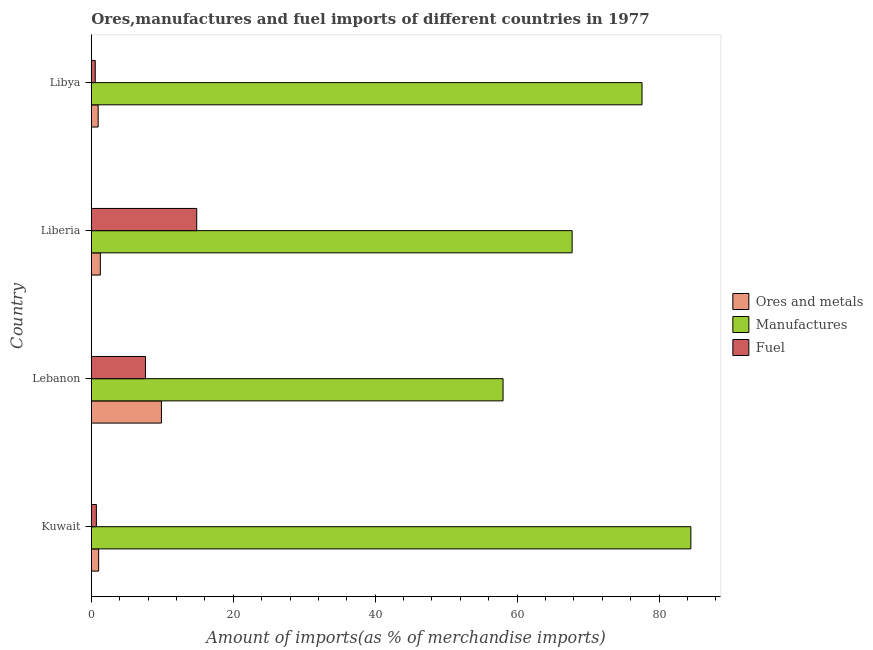How many different coloured bars are there?
Make the answer very short. 3. Are the number of bars per tick equal to the number of legend labels?
Offer a terse response. Yes. How many bars are there on the 3rd tick from the top?
Provide a short and direct response. 3. What is the label of the 3rd group of bars from the top?
Provide a succinct answer. Lebanon. In how many cases, is the number of bars for a given country not equal to the number of legend labels?
Offer a very short reply. 0. What is the percentage of manufactures imports in Libya?
Provide a succinct answer. 77.6. Across all countries, what is the maximum percentage of manufactures imports?
Keep it short and to the point. 84.49. Across all countries, what is the minimum percentage of fuel imports?
Give a very brief answer. 0.56. In which country was the percentage of fuel imports maximum?
Offer a very short reply. Liberia. In which country was the percentage of ores and metals imports minimum?
Offer a very short reply. Libya. What is the total percentage of fuel imports in the graph?
Make the answer very short. 23.76. What is the difference between the percentage of fuel imports in Kuwait and that in Lebanon?
Give a very brief answer. -6.92. What is the difference between the percentage of manufactures imports in Kuwait and the percentage of fuel imports in Libya?
Give a very brief answer. 83.93. What is the average percentage of fuel imports per country?
Provide a short and direct response. 5.94. What is the difference between the percentage of manufactures imports and percentage of ores and metals imports in Libya?
Give a very brief answer. 76.64. In how many countries, is the percentage of ores and metals imports greater than 72 %?
Offer a terse response. 0. What is the ratio of the percentage of manufactures imports in Kuwait to that in Libya?
Make the answer very short. 1.09. Is the difference between the percentage of manufactures imports in Kuwait and Lebanon greater than the difference between the percentage of fuel imports in Kuwait and Lebanon?
Your answer should be very brief. Yes. What is the difference between the highest and the second highest percentage of ores and metals imports?
Your answer should be very brief. 8.61. What is the difference between the highest and the lowest percentage of ores and metals imports?
Ensure brevity in your answer.  8.92. What does the 3rd bar from the top in Liberia represents?
Your answer should be compact. Ores and metals. What does the 3rd bar from the bottom in Libya represents?
Ensure brevity in your answer.  Fuel. Is it the case that in every country, the sum of the percentage of ores and metals imports and percentage of manufactures imports is greater than the percentage of fuel imports?
Give a very brief answer. Yes. How many bars are there?
Your answer should be very brief. 12. How many countries are there in the graph?
Provide a short and direct response. 4. Are the values on the major ticks of X-axis written in scientific E-notation?
Make the answer very short. No. Does the graph contain any zero values?
Your answer should be very brief. No. Where does the legend appear in the graph?
Make the answer very short. Center right. What is the title of the graph?
Provide a succinct answer. Ores,manufactures and fuel imports of different countries in 1977. Does "Unemployment benefits" appear as one of the legend labels in the graph?
Give a very brief answer. No. What is the label or title of the X-axis?
Keep it short and to the point. Amount of imports(as % of merchandise imports). What is the Amount of imports(as % of merchandise imports) in Ores and metals in Kuwait?
Provide a succinct answer. 1.04. What is the Amount of imports(as % of merchandise imports) in Manufactures in Kuwait?
Keep it short and to the point. 84.49. What is the Amount of imports(as % of merchandise imports) in Fuel in Kuwait?
Give a very brief answer. 0.71. What is the Amount of imports(as % of merchandise imports) of Ores and metals in Lebanon?
Make the answer very short. 9.88. What is the Amount of imports(as % of merchandise imports) of Manufactures in Lebanon?
Make the answer very short. 58.02. What is the Amount of imports(as % of merchandise imports) in Fuel in Lebanon?
Offer a very short reply. 7.63. What is the Amount of imports(as % of merchandise imports) in Ores and metals in Liberia?
Your answer should be compact. 1.27. What is the Amount of imports(as % of merchandise imports) in Manufactures in Liberia?
Your answer should be compact. 67.76. What is the Amount of imports(as % of merchandise imports) of Fuel in Liberia?
Provide a succinct answer. 14.86. What is the Amount of imports(as % of merchandise imports) of Ores and metals in Libya?
Your response must be concise. 0.97. What is the Amount of imports(as % of merchandise imports) of Manufactures in Libya?
Give a very brief answer. 77.6. What is the Amount of imports(as % of merchandise imports) in Fuel in Libya?
Make the answer very short. 0.56. Across all countries, what is the maximum Amount of imports(as % of merchandise imports) of Ores and metals?
Offer a very short reply. 9.88. Across all countries, what is the maximum Amount of imports(as % of merchandise imports) of Manufactures?
Offer a very short reply. 84.49. Across all countries, what is the maximum Amount of imports(as % of merchandise imports) in Fuel?
Make the answer very short. 14.86. Across all countries, what is the minimum Amount of imports(as % of merchandise imports) in Ores and metals?
Provide a succinct answer. 0.97. Across all countries, what is the minimum Amount of imports(as % of merchandise imports) of Manufactures?
Ensure brevity in your answer.  58.02. Across all countries, what is the minimum Amount of imports(as % of merchandise imports) of Fuel?
Make the answer very short. 0.56. What is the total Amount of imports(as % of merchandise imports) in Ores and metals in the graph?
Your answer should be very brief. 13.16. What is the total Amount of imports(as % of merchandise imports) of Manufactures in the graph?
Offer a very short reply. 287.87. What is the total Amount of imports(as % of merchandise imports) in Fuel in the graph?
Give a very brief answer. 23.76. What is the difference between the Amount of imports(as % of merchandise imports) of Ores and metals in Kuwait and that in Lebanon?
Your answer should be compact. -8.85. What is the difference between the Amount of imports(as % of merchandise imports) of Manufactures in Kuwait and that in Lebanon?
Give a very brief answer. 26.46. What is the difference between the Amount of imports(as % of merchandise imports) in Fuel in Kuwait and that in Lebanon?
Offer a very short reply. -6.92. What is the difference between the Amount of imports(as % of merchandise imports) of Ores and metals in Kuwait and that in Liberia?
Give a very brief answer. -0.24. What is the difference between the Amount of imports(as % of merchandise imports) in Manufactures in Kuwait and that in Liberia?
Your answer should be compact. 16.73. What is the difference between the Amount of imports(as % of merchandise imports) of Fuel in Kuwait and that in Liberia?
Your answer should be very brief. -14.14. What is the difference between the Amount of imports(as % of merchandise imports) of Ores and metals in Kuwait and that in Libya?
Provide a succinct answer. 0.07. What is the difference between the Amount of imports(as % of merchandise imports) in Manufactures in Kuwait and that in Libya?
Your response must be concise. 6.88. What is the difference between the Amount of imports(as % of merchandise imports) in Fuel in Kuwait and that in Libya?
Your response must be concise. 0.16. What is the difference between the Amount of imports(as % of merchandise imports) of Ores and metals in Lebanon and that in Liberia?
Offer a terse response. 8.61. What is the difference between the Amount of imports(as % of merchandise imports) in Manufactures in Lebanon and that in Liberia?
Keep it short and to the point. -9.73. What is the difference between the Amount of imports(as % of merchandise imports) of Fuel in Lebanon and that in Liberia?
Your answer should be compact. -7.22. What is the difference between the Amount of imports(as % of merchandise imports) in Ores and metals in Lebanon and that in Libya?
Your answer should be compact. 8.92. What is the difference between the Amount of imports(as % of merchandise imports) of Manufactures in Lebanon and that in Libya?
Give a very brief answer. -19.58. What is the difference between the Amount of imports(as % of merchandise imports) of Fuel in Lebanon and that in Libya?
Make the answer very short. 7.08. What is the difference between the Amount of imports(as % of merchandise imports) in Ores and metals in Liberia and that in Libya?
Provide a short and direct response. 0.31. What is the difference between the Amount of imports(as % of merchandise imports) in Manufactures in Liberia and that in Libya?
Your response must be concise. -9.85. What is the difference between the Amount of imports(as % of merchandise imports) of Fuel in Liberia and that in Libya?
Your answer should be very brief. 14.3. What is the difference between the Amount of imports(as % of merchandise imports) of Ores and metals in Kuwait and the Amount of imports(as % of merchandise imports) of Manufactures in Lebanon?
Provide a succinct answer. -56.99. What is the difference between the Amount of imports(as % of merchandise imports) of Ores and metals in Kuwait and the Amount of imports(as % of merchandise imports) of Fuel in Lebanon?
Make the answer very short. -6.6. What is the difference between the Amount of imports(as % of merchandise imports) in Manufactures in Kuwait and the Amount of imports(as % of merchandise imports) in Fuel in Lebanon?
Ensure brevity in your answer.  76.85. What is the difference between the Amount of imports(as % of merchandise imports) in Ores and metals in Kuwait and the Amount of imports(as % of merchandise imports) in Manufactures in Liberia?
Provide a succinct answer. -66.72. What is the difference between the Amount of imports(as % of merchandise imports) of Ores and metals in Kuwait and the Amount of imports(as % of merchandise imports) of Fuel in Liberia?
Your answer should be very brief. -13.82. What is the difference between the Amount of imports(as % of merchandise imports) in Manufactures in Kuwait and the Amount of imports(as % of merchandise imports) in Fuel in Liberia?
Keep it short and to the point. 69.63. What is the difference between the Amount of imports(as % of merchandise imports) in Ores and metals in Kuwait and the Amount of imports(as % of merchandise imports) in Manufactures in Libya?
Your response must be concise. -76.57. What is the difference between the Amount of imports(as % of merchandise imports) of Ores and metals in Kuwait and the Amount of imports(as % of merchandise imports) of Fuel in Libya?
Keep it short and to the point. 0.48. What is the difference between the Amount of imports(as % of merchandise imports) of Manufactures in Kuwait and the Amount of imports(as % of merchandise imports) of Fuel in Libya?
Offer a terse response. 83.93. What is the difference between the Amount of imports(as % of merchandise imports) of Ores and metals in Lebanon and the Amount of imports(as % of merchandise imports) of Manufactures in Liberia?
Your response must be concise. -57.87. What is the difference between the Amount of imports(as % of merchandise imports) in Ores and metals in Lebanon and the Amount of imports(as % of merchandise imports) in Fuel in Liberia?
Keep it short and to the point. -4.97. What is the difference between the Amount of imports(as % of merchandise imports) in Manufactures in Lebanon and the Amount of imports(as % of merchandise imports) in Fuel in Liberia?
Offer a terse response. 43.17. What is the difference between the Amount of imports(as % of merchandise imports) of Ores and metals in Lebanon and the Amount of imports(as % of merchandise imports) of Manufactures in Libya?
Make the answer very short. -67.72. What is the difference between the Amount of imports(as % of merchandise imports) in Ores and metals in Lebanon and the Amount of imports(as % of merchandise imports) in Fuel in Libya?
Provide a short and direct response. 9.33. What is the difference between the Amount of imports(as % of merchandise imports) of Manufactures in Lebanon and the Amount of imports(as % of merchandise imports) of Fuel in Libya?
Your response must be concise. 57.47. What is the difference between the Amount of imports(as % of merchandise imports) in Ores and metals in Liberia and the Amount of imports(as % of merchandise imports) in Manufactures in Libya?
Provide a short and direct response. -76.33. What is the difference between the Amount of imports(as % of merchandise imports) of Ores and metals in Liberia and the Amount of imports(as % of merchandise imports) of Fuel in Libya?
Offer a very short reply. 0.72. What is the difference between the Amount of imports(as % of merchandise imports) in Manufactures in Liberia and the Amount of imports(as % of merchandise imports) in Fuel in Libya?
Give a very brief answer. 67.2. What is the average Amount of imports(as % of merchandise imports) in Ores and metals per country?
Offer a terse response. 3.29. What is the average Amount of imports(as % of merchandise imports) of Manufactures per country?
Keep it short and to the point. 71.97. What is the average Amount of imports(as % of merchandise imports) of Fuel per country?
Give a very brief answer. 5.94. What is the difference between the Amount of imports(as % of merchandise imports) in Ores and metals and Amount of imports(as % of merchandise imports) in Manufactures in Kuwait?
Offer a very short reply. -83.45. What is the difference between the Amount of imports(as % of merchandise imports) in Ores and metals and Amount of imports(as % of merchandise imports) in Fuel in Kuwait?
Offer a very short reply. 0.32. What is the difference between the Amount of imports(as % of merchandise imports) of Manufactures and Amount of imports(as % of merchandise imports) of Fuel in Kuwait?
Offer a terse response. 83.77. What is the difference between the Amount of imports(as % of merchandise imports) in Ores and metals and Amount of imports(as % of merchandise imports) in Manufactures in Lebanon?
Your answer should be very brief. -48.14. What is the difference between the Amount of imports(as % of merchandise imports) in Ores and metals and Amount of imports(as % of merchandise imports) in Fuel in Lebanon?
Make the answer very short. 2.25. What is the difference between the Amount of imports(as % of merchandise imports) in Manufactures and Amount of imports(as % of merchandise imports) in Fuel in Lebanon?
Give a very brief answer. 50.39. What is the difference between the Amount of imports(as % of merchandise imports) of Ores and metals and Amount of imports(as % of merchandise imports) of Manufactures in Liberia?
Offer a terse response. -66.48. What is the difference between the Amount of imports(as % of merchandise imports) in Ores and metals and Amount of imports(as % of merchandise imports) in Fuel in Liberia?
Provide a succinct answer. -13.58. What is the difference between the Amount of imports(as % of merchandise imports) of Manufactures and Amount of imports(as % of merchandise imports) of Fuel in Liberia?
Offer a very short reply. 52.9. What is the difference between the Amount of imports(as % of merchandise imports) of Ores and metals and Amount of imports(as % of merchandise imports) of Manufactures in Libya?
Provide a succinct answer. -76.64. What is the difference between the Amount of imports(as % of merchandise imports) of Ores and metals and Amount of imports(as % of merchandise imports) of Fuel in Libya?
Your answer should be compact. 0.41. What is the difference between the Amount of imports(as % of merchandise imports) in Manufactures and Amount of imports(as % of merchandise imports) in Fuel in Libya?
Keep it short and to the point. 77.05. What is the ratio of the Amount of imports(as % of merchandise imports) in Ores and metals in Kuwait to that in Lebanon?
Provide a succinct answer. 0.1. What is the ratio of the Amount of imports(as % of merchandise imports) of Manufactures in Kuwait to that in Lebanon?
Provide a succinct answer. 1.46. What is the ratio of the Amount of imports(as % of merchandise imports) in Fuel in Kuwait to that in Lebanon?
Offer a very short reply. 0.09. What is the ratio of the Amount of imports(as % of merchandise imports) in Ores and metals in Kuwait to that in Liberia?
Your answer should be compact. 0.81. What is the ratio of the Amount of imports(as % of merchandise imports) in Manufactures in Kuwait to that in Liberia?
Provide a short and direct response. 1.25. What is the ratio of the Amount of imports(as % of merchandise imports) of Fuel in Kuwait to that in Liberia?
Provide a succinct answer. 0.05. What is the ratio of the Amount of imports(as % of merchandise imports) of Ores and metals in Kuwait to that in Libya?
Provide a succinct answer. 1.07. What is the ratio of the Amount of imports(as % of merchandise imports) in Manufactures in Kuwait to that in Libya?
Offer a very short reply. 1.09. What is the ratio of the Amount of imports(as % of merchandise imports) in Fuel in Kuwait to that in Libya?
Your answer should be very brief. 1.28. What is the ratio of the Amount of imports(as % of merchandise imports) in Ores and metals in Lebanon to that in Liberia?
Offer a terse response. 7.76. What is the ratio of the Amount of imports(as % of merchandise imports) of Manufactures in Lebanon to that in Liberia?
Offer a terse response. 0.86. What is the ratio of the Amount of imports(as % of merchandise imports) of Fuel in Lebanon to that in Liberia?
Provide a succinct answer. 0.51. What is the ratio of the Amount of imports(as % of merchandise imports) of Ores and metals in Lebanon to that in Libya?
Your response must be concise. 10.21. What is the ratio of the Amount of imports(as % of merchandise imports) in Manufactures in Lebanon to that in Libya?
Your answer should be compact. 0.75. What is the ratio of the Amount of imports(as % of merchandise imports) of Fuel in Lebanon to that in Libya?
Your response must be concise. 13.7. What is the ratio of the Amount of imports(as % of merchandise imports) of Ores and metals in Liberia to that in Libya?
Offer a terse response. 1.32. What is the ratio of the Amount of imports(as % of merchandise imports) of Manufactures in Liberia to that in Libya?
Provide a succinct answer. 0.87. What is the ratio of the Amount of imports(as % of merchandise imports) of Fuel in Liberia to that in Libya?
Give a very brief answer. 26.66. What is the difference between the highest and the second highest Amount of imports(as % of merchandise imports) of Ores and metals?
Offer a terse response. 8.61. What is the difference between the highest and the second highest Amount of imports(as % of merchandise imports) in Manufactures?
Offer a terse response. 6.88. What is the difference between the highest and the second highest Amount of imports(as % of merchandise imports) in Fuel?
Give a very brief answer. 7.22. What is the difference between the highest and the lowest Amount of imports(as % of merchandise imports) in Ores and metals?
Your answer should be compact. 8.92. What is the difference between the highest and the lowest Amount of imports(as % of merchandise imports) of Manufactures?
Your answer should be compact. 26.46. What is the difference between the highest and the lowest Amount of imports(as % of merchandise imports) of Fuel?
Keep it short and to the point. 14.3. 